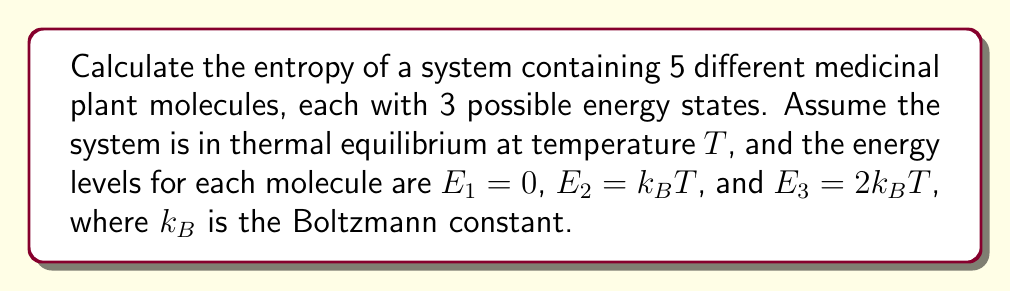Can you answer this question? To calculate the entropy of this system, we'll follow these steps:

1) First, we need to calculate the partition function Z for a single molecule:
   $$Z = e^{-E_1/k_BT} + e^{-E_2/k_BT} + e^{-E_3/k_BT}$$
   $$Z = e^0 + e^{-1} + e^{-2} = 1 + e^{-1} + e^{-2}$$

2) The probability of a molecule being in each state is:
   $$p_1 = \frac{e^0}{Z}, p_2 = \frac{e^{-1}}{Z}, p_3 = \frac{e^{-2}}{Z}$$

3) The entropy of a single molecule is given by:
   $$S_1 = -k_B\sum_{i=1}^3 p_i \ln p_i$$

4) Substituting the probabilities:
   $$S_1 = -k_B(\frac{1}{Z}\ln\frac{1}{Z} + \frac{e^{-1}}{Z}\ln\frac{e^{-1}}{Z} + \frac{e^{-2}}{Z}\ln\frac{e^{-2}}{Z})$$

5) Simplifying:
   $$S_1 = k_B(\ln Z - \frac{1}{Z} - \frac{e^{-1}}{Z} - 2\frac{e^{-2}}{Z})$$

6) For 5 independent molecules, the total entropy is:
   $$S = 5S_1 = 5k_B(\ln Z - \frac{1}{Z} - \frac{e^{-1}}{Z} - 2\frac{e^{-2}}{Z})$$

7) Substituting the value of Z:
   $$S = 5k_B(\ln(1+e^{-1}+e^{-2}) - \frac{1+e^{-1}+2e^{-2}}{1+e^{-1}+e^{-2}})$$
Answer: $5k_B(\ln(1+e^{-1}+e^{-2}) - \frac{1+e^{-1}+2e^{-2}}{1+e^{-1}+e^{-2}})$ 